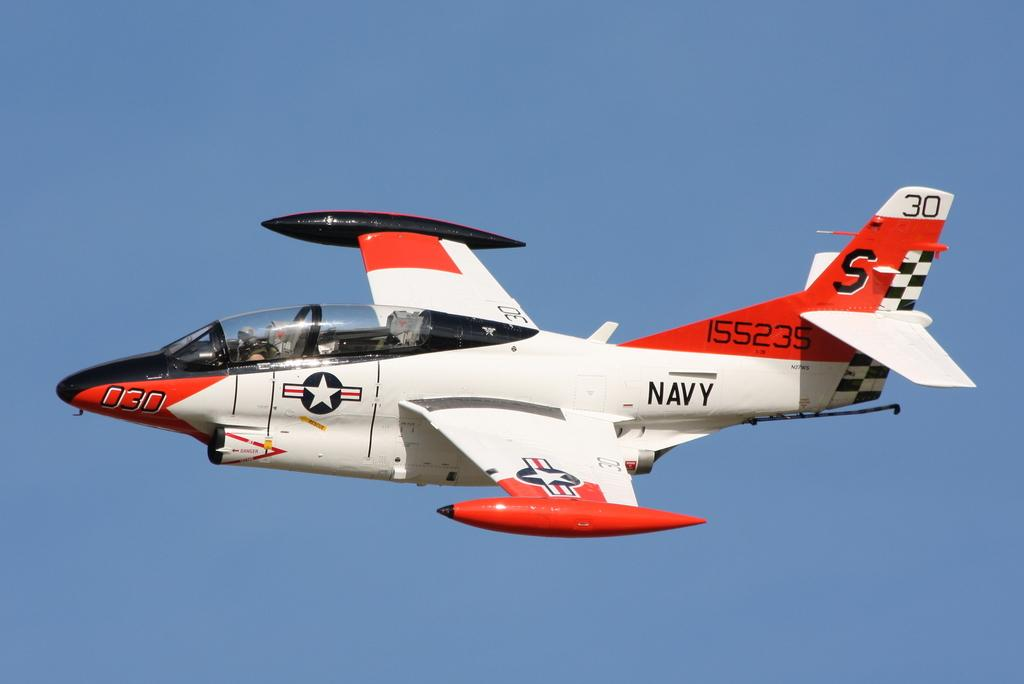<image>
Relay a brief, clear account of the picture shown. A red and white jet with the Navy logo written on the tail. 